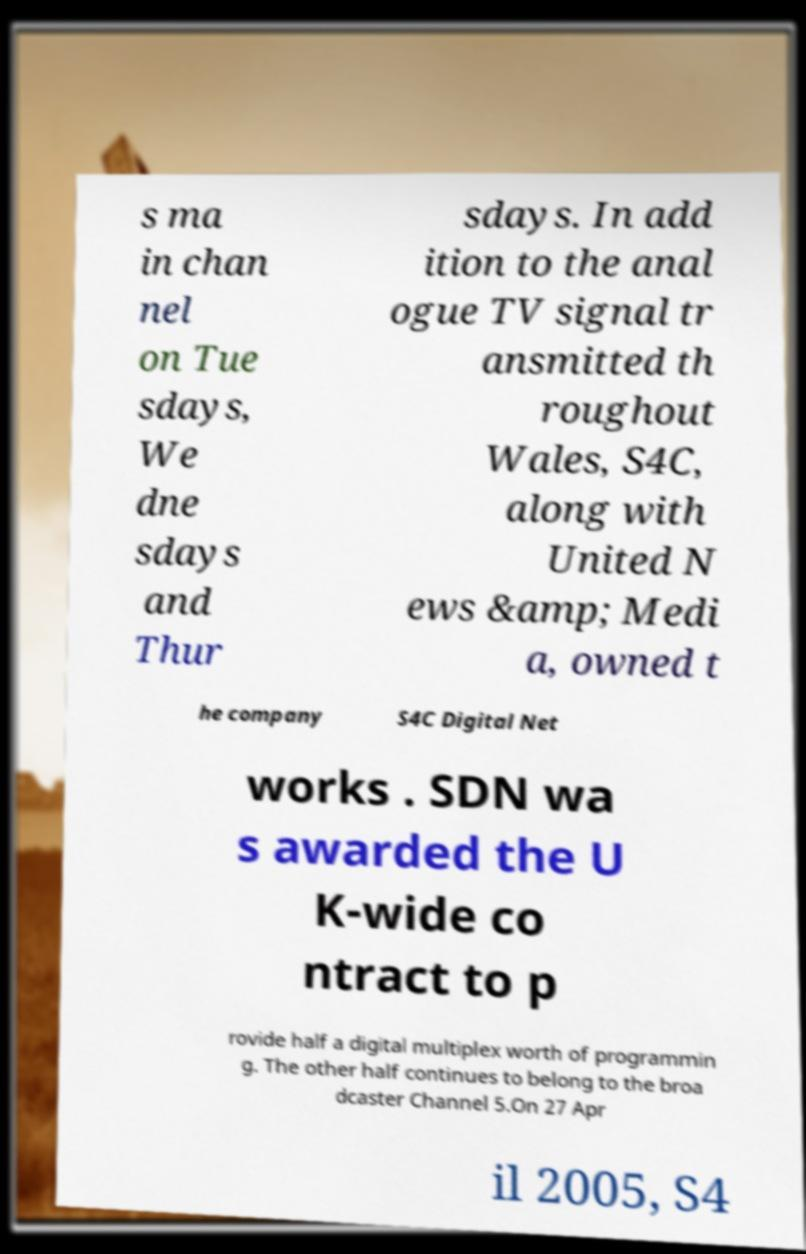Please read and relay the text visible in this image. What does it say? s ma in chan nel on Tue sdays, We dne sdays and Thur sdays. In add ition to the anal ogue TV signal tr ansmitted th roughout Wales, S4C, along with United N ews &amp; Medi a, owned t he company S4C Digital Net works . SDN wa s awarded the U K-wide co ntract to p rovide half a digital multiplex worth of programmin g. The other half continues to belong to the broa dcaster Channel 5.On 27 Apr il 2005, S4 